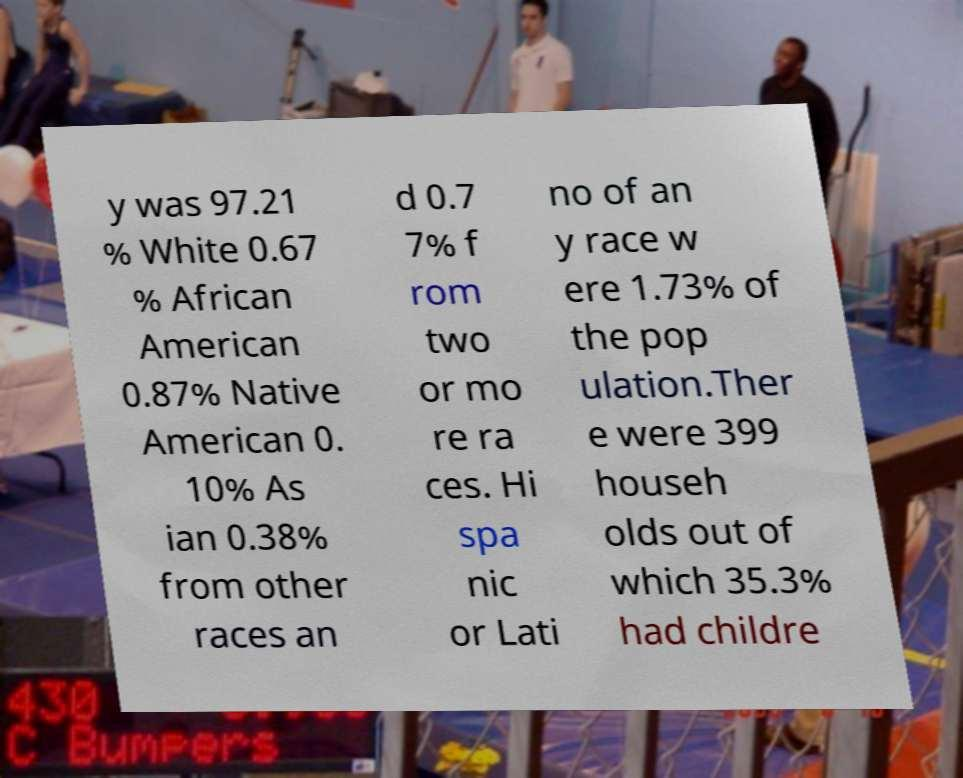There's text embedded in this image that I need extracted. Can you transcribe it verbatim? y was 97.21 % White 0.67 % African American 0.87% Native American 0. 10% As ian 0.38% from other races an d 0.7 7% f rom two or mo re ra ces. Hi spa nic or Lati no of an y race w ere 1.73% of the pop ulation.Ther e were 399 househ olds out of which 35.3% had childre 